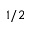Convert formula to latex. <formula><loc_0><loc_0><loc_500><loc_500>1 / 2</formula> 